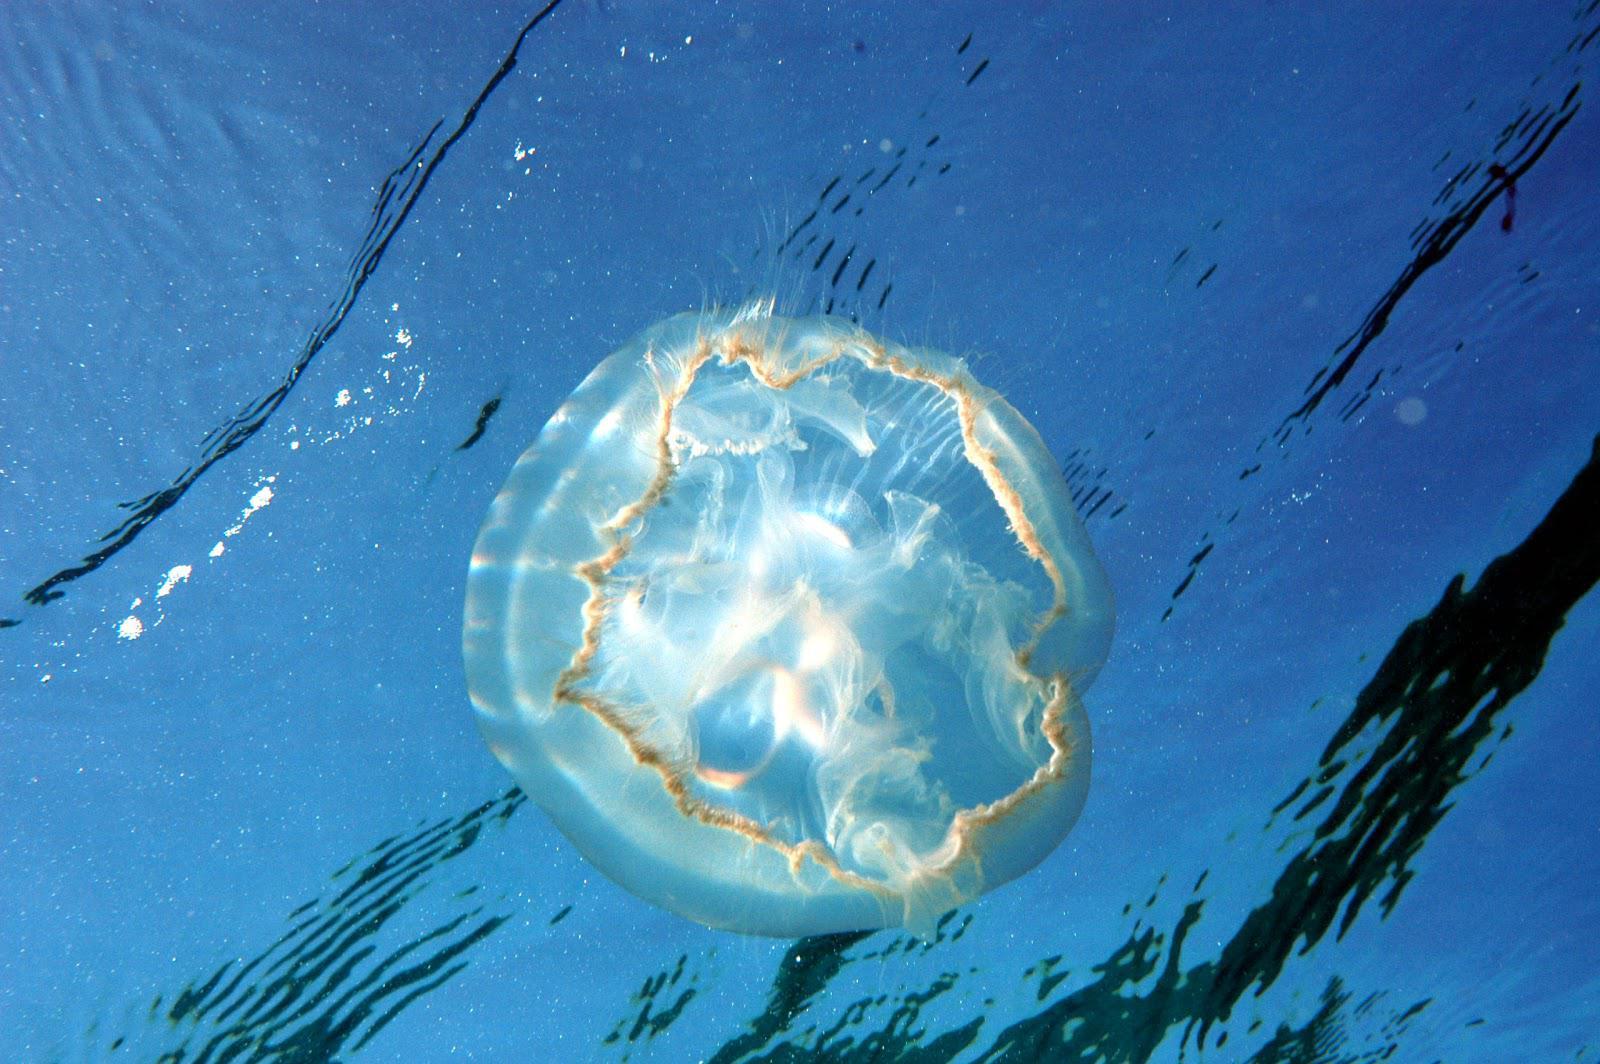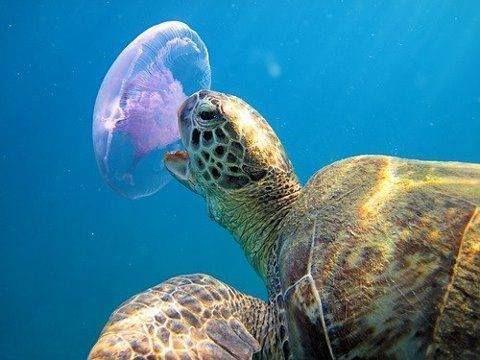The first image is the image on the left, the second image is the image on the right. Evaluate the accuracy of this statement regarding the images: "One of the images shows a tortoise interacting with a jellyfish.". Is it true? Answer yes or no. Yes. The first image is the image on the left, the second image is the image on the right. For the images displayed, is the sentence "The left image contains one round jellyfish with glowing white color, and the right image features a sea turtle next to a round shape." factually correct? Answer yes or no. Yes. 